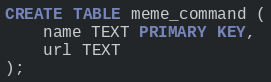Convert code to text. <code><loc_0><loc_0><loc_500><loc_500><_SQL_>CREATE TABLE meme_command (
    name TEXT PRIMARY KEY,
    url TEXT
);
</code> 